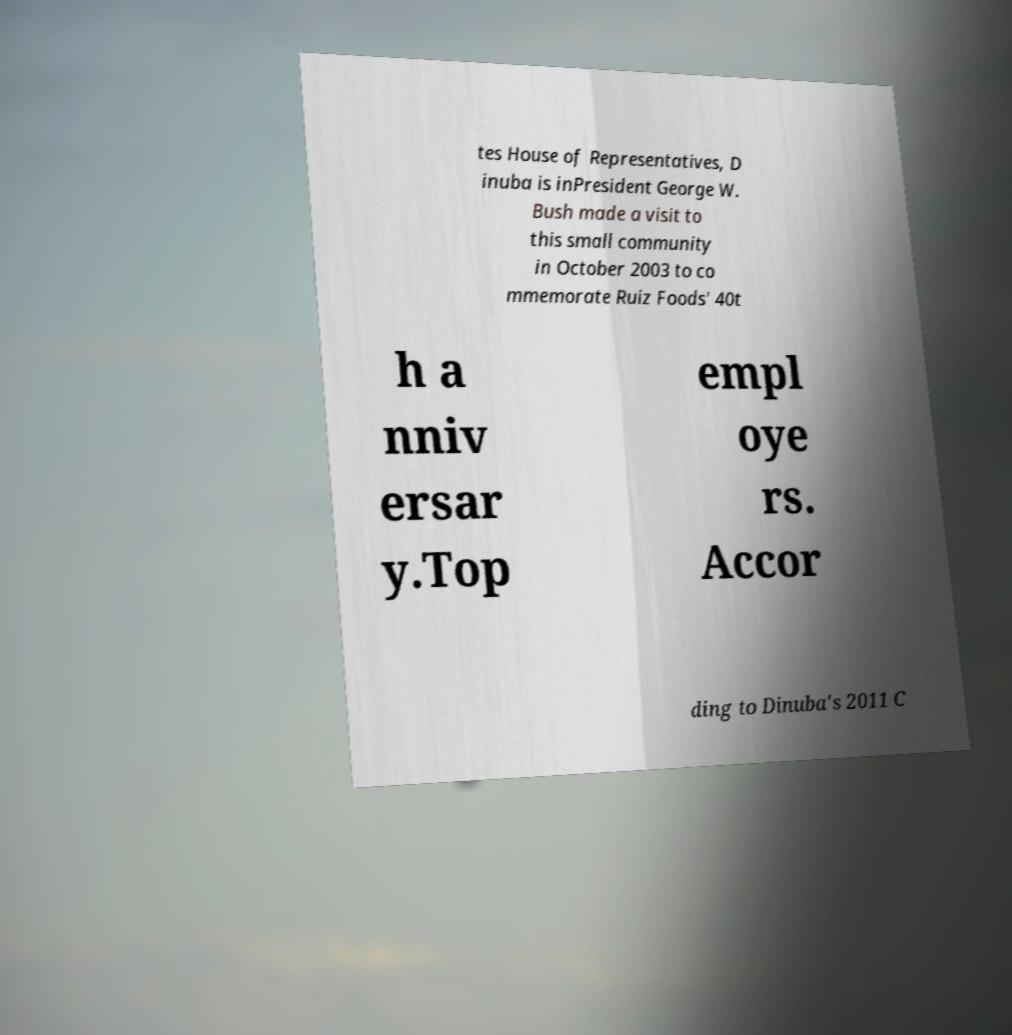Please identify and transcribe the text found in this image. tes House of Representatives, D inuba is inPresident George W. Bush made a visit to this small community in October 2003 to co mmemorate Ruiz Foods' 40t h a nniv ersar y.Top empl oye rs. Accor ding to Dinuba's 2011 C 